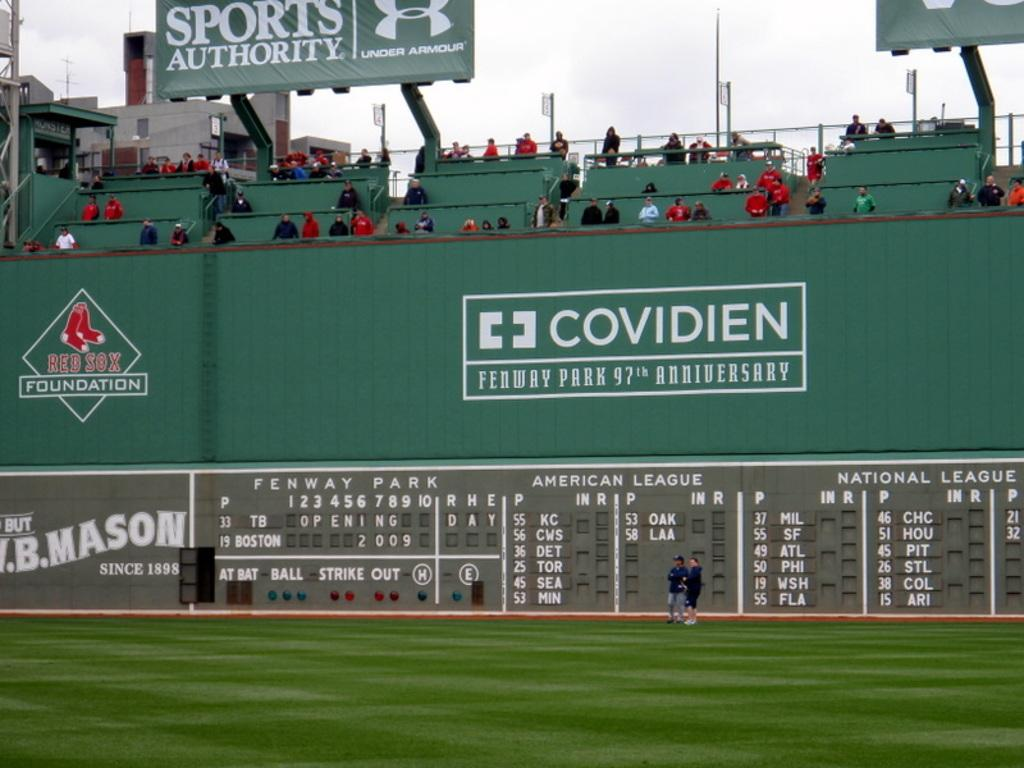<image>
Describe the image concisely. Spectators at Fenway Park watching a game between Boston and Tampa Bay 